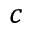Convert formula to latex. <formula><loc_0><loc_0><loc_500><loc_500>c</formula> 